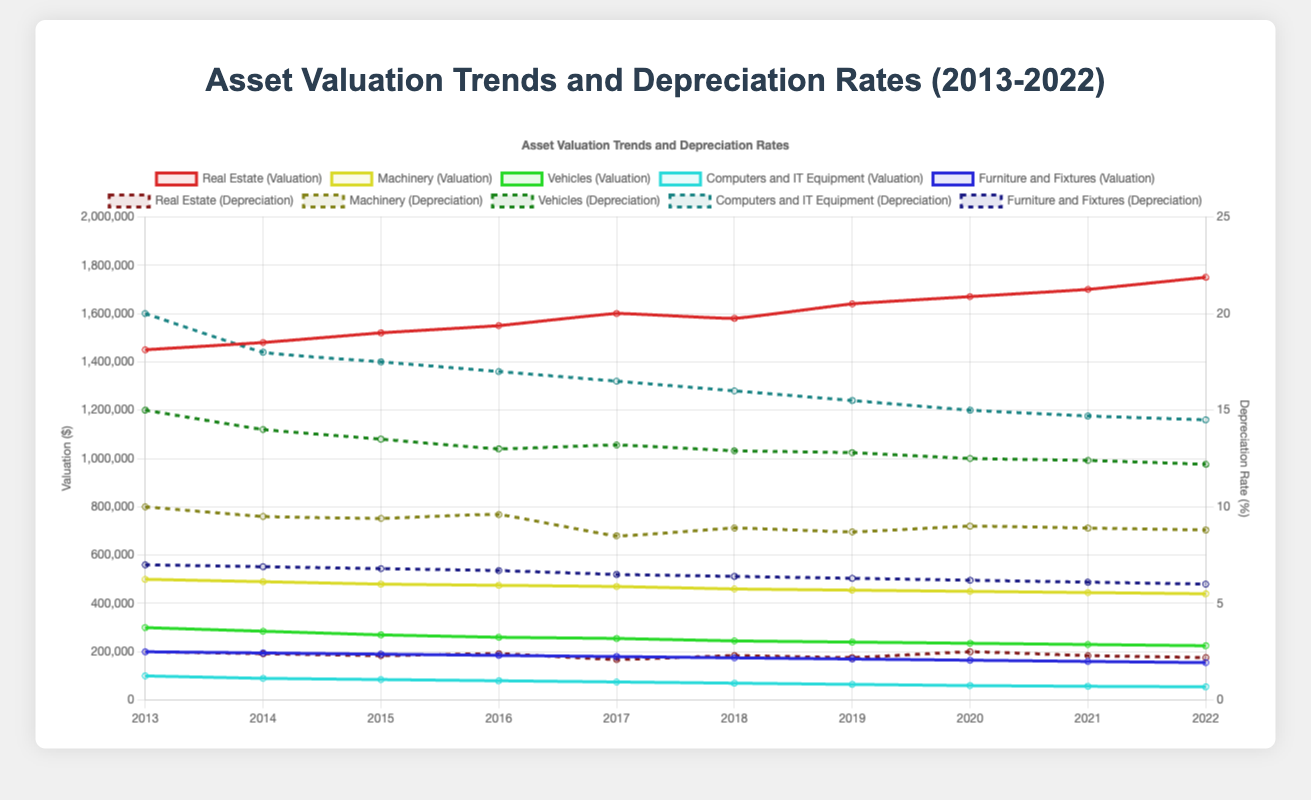What was the highest valuation trend for Real Estate, and in which year did it occur? By examining the Real Estate asset data, the highest valuation trend is $1,750,000. This occurred in 2022.
Answer: $1,750,000 in 2022 Which asset had the highest depreciation rate in 2013, and what was the rate? Analyzing the depreciation rates for 2013, Computers and IT Equipment had the highest depreciation rate at 20.0%.
Answer: Computers and IT Equipment with 20.0% Compare the valuation trends for Vehicles between 2015 and 2022. How much did the valuation decrease? The valuation for Vehicles in 2015 was $270,000, and in 2022 it was $225,000. The decrease is $270,000 - $225,000 = $45,000.
Answer: $45,000 Which asset experienced the smallest change in valuation trends over the ten years? By comparing the valuation differences for all assets from 2013 to 2022, Real Estate showed the smallest change, increasing from $1,450,000 to $1,750,000, a difference of $300,000.
Answer: Real Estate In which year was the depreciation rate for Machinery at its minimum, and what was the rate? Observing the depreciation rates for Machinery, the minimum rate was 8.5% in 2017.
Answer: 2017 at 8.5% Calculate the average depreciation rate for Furniture and Fixtures over the ten years. Summing the depreciation rates for Furniture and Fixtures: (7.0 + 6.9 + 6.8 + 6.7 + 6.5 + 6.4 + 6.3 + 6.2 + 6.1 + 6.0) = 64.9. The average is 64.9 / 10 = 6.49%.
Answer: 6.49% Identify the year with the highest general depreciation rate across all assets combined. Summing the depreciation rates per year across all assets and identifying the highest sum, 2013 has the highest with a combined rate of 54.5%.
Answer: 2013 Which asset had a depreciation rate closest to 10% in 2018? Reviewing the 2018 depreciation rates, Machinery had a depreciation rate of 8.9%, which is closest to 10%.
Answer: Machinery with 8.9% How much did the depreciation rate for Computers and IT Equipment decrease from 2013 to 2022? The depreciation rate for Computers and IT Equipment was 20.0% in 2013 and 14.5% in 2022. The decrease is 20.0% - 14.5% = 5.5%.
Answer: 5.5% Compare the valuation trends of Real Estate and Machinery in 2016. Which was higher and by how much? In 2016, the valuation trend for Real Estate was $1,550,000 and for Machinery, it was $475,000. The difference is $1,550,000 - $475,000 = $1,075,000, with Real Estate being higher.
Answer: Real Estate by $1,075,000 